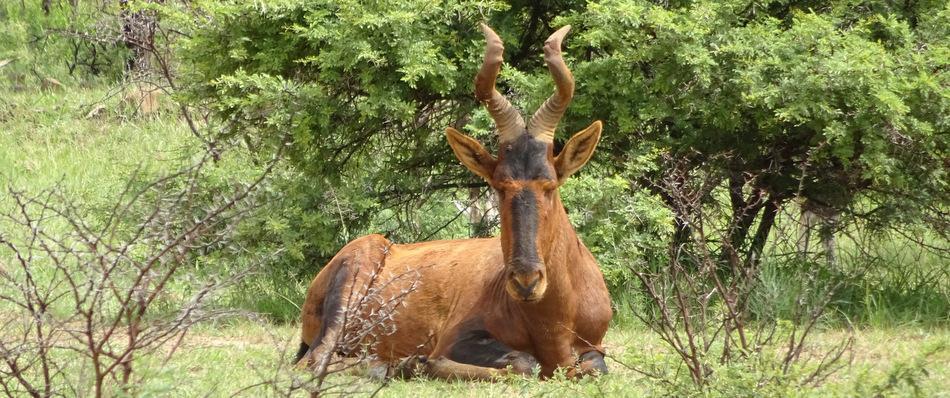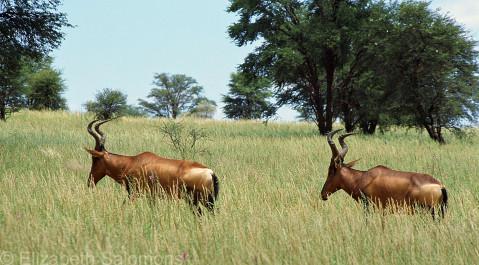The first image is the image on the left, the second image is the image on the right. Examine the images to the left and right. Is the description "An image contains just one horned animal in a field." accurate? Answer yes or no. Yes. The first image is the image on the left, the second image is the image on the right. Evaluate the accuracy of this statement regarding the images: "There is only one animal in one of the images.". Is it true? Answer yes or no. Yes. 